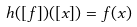Convert formula to latex. <formula><loc_0><loc_0><loc_500><loc_500>h ( [ f ] ) ( [ x ] ) = f ( x )</formula> 